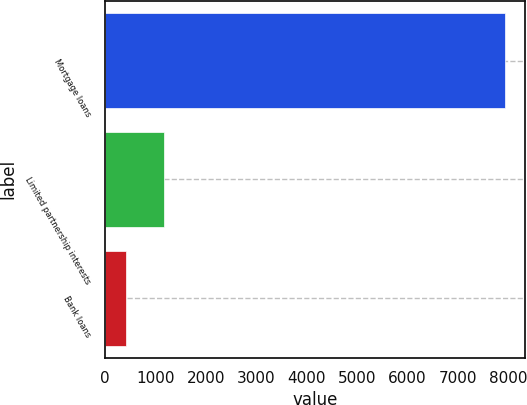<chart> <loc_0><loc_0><loc_500><loc_500><bar_chart><fcel>Mortgage loans<fcel>Limited partnership interests<fcel>Bank loans<nl><fcel>7935<fcel>1171.5<fcel>420<nl></chart> 